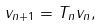Convert formula to latex. <formula><loc_0><loc_0><loc_500><loc_500>v _ { n + 1 } = T _ { n } v _ { n } ,</formula> 